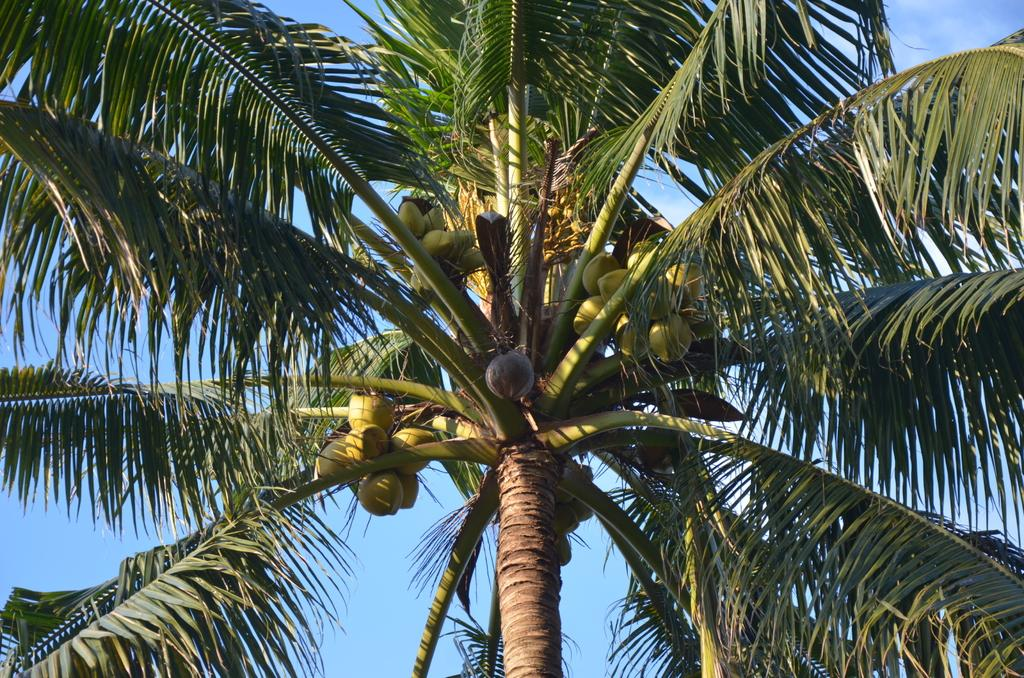What is the main subject of the image? The main subject of the image is a group of coconuts. What else can be seen on the tree in the image? There are leaves on the branches of the tree in the image. What is visible in the background of the image? The sky is visible in the background of the image. How many creatures are holding onto the coconuts in the image? There are no creatures present in the image, so none are holding onto the coconuts. 